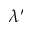Convert formula to latex. <formula><loc_0><loc_0><loc_500><loc_500>\lambda ^ { \prime }</formula> 